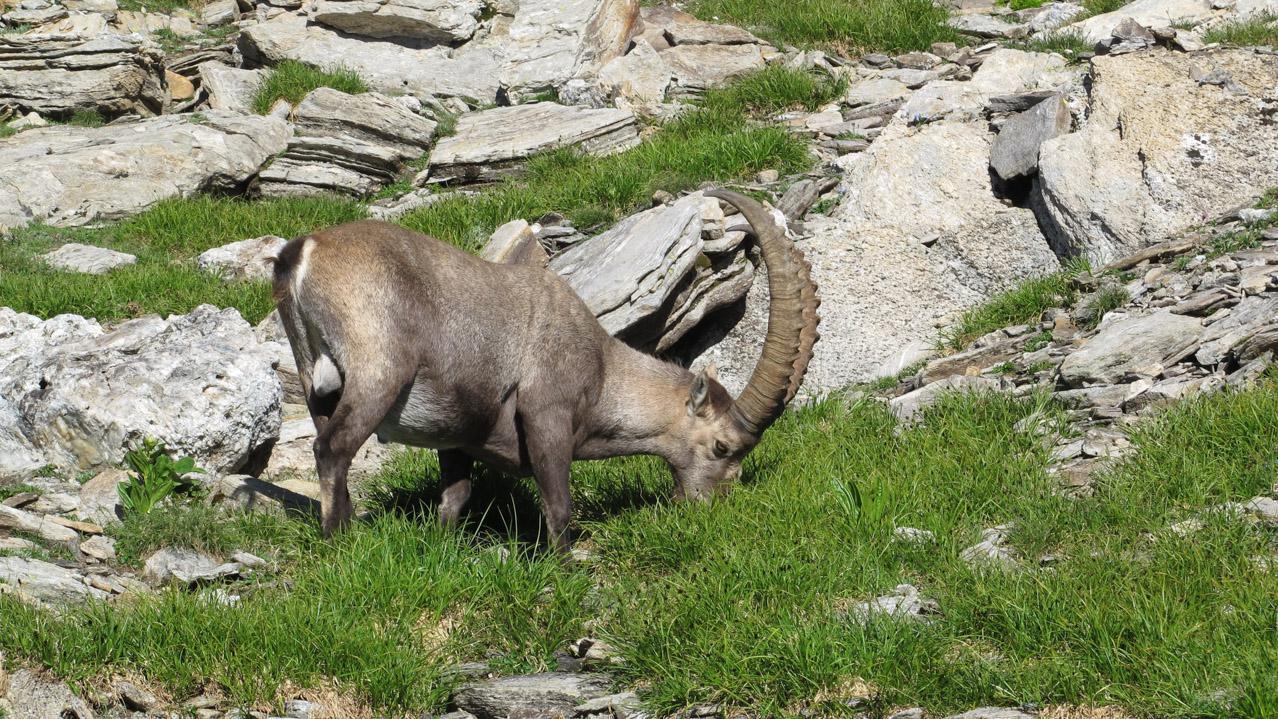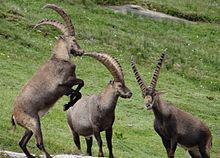The first image is the image on the left, the second image is the image on the right. For the images displayed, is the sentence "There is a total of four animals." factually correct? Answer yes or no. Yes. 